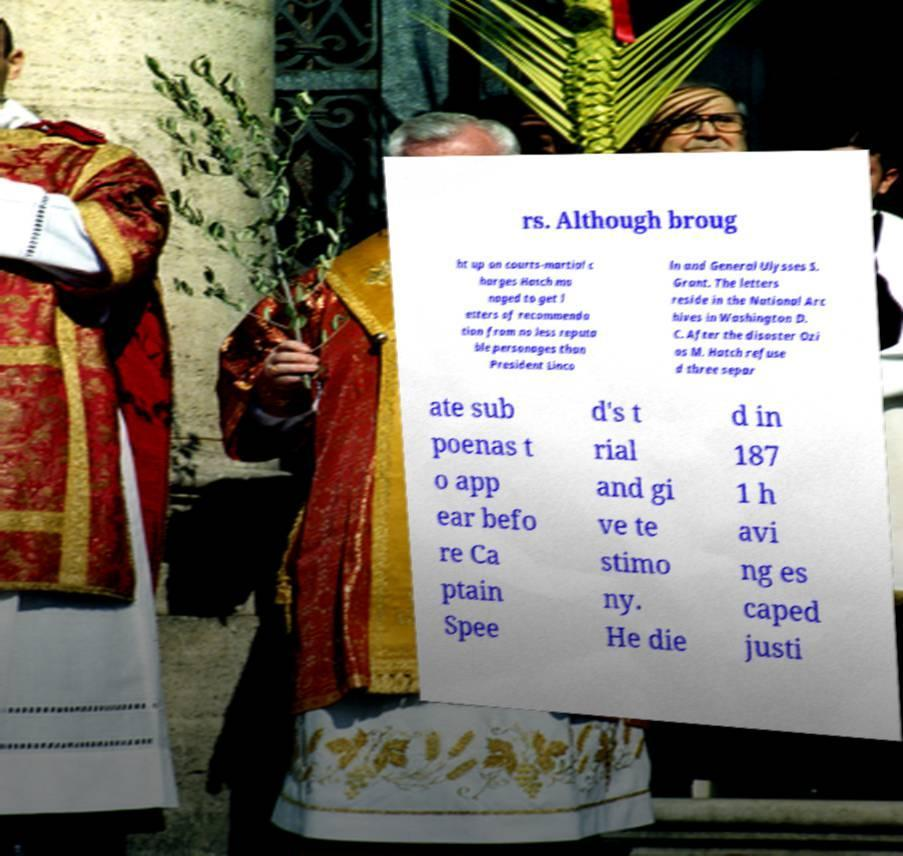What messages or text are displayed in this image? I need them in a readable, typed format. rs. Although broug ht up on courts-martial c harges Hatch ma naged to get l etters of recommenda tion from no less reputa ble personages than President Linco ln and General Ulysses S. Grant. The letters reside in the National Arc hives in Washington D. C. After the disaster Ozi as M. Hatch refuse d three separ ate sub poenas t o app ear befo re Ca ptain Spee d's t rial and gi ve te stimo ny. He die d in 187 1 h avi ng es caped justi 